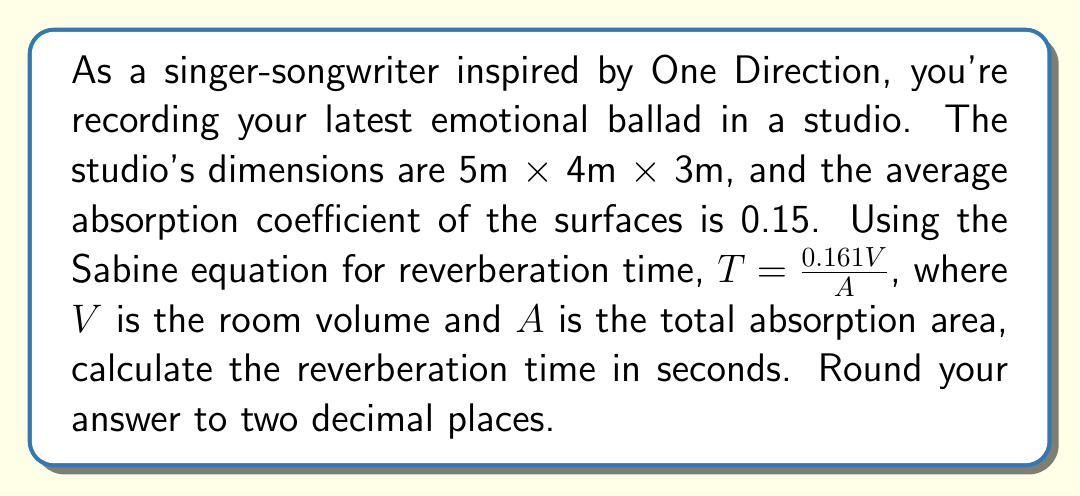Could you help me with this problem? Let's approach this step-by-step:

1) First, we need to calculate the volume of the room:
   $V = 5m \times 4m \times 3m = 60m^3$

2) Next, we need to calculate the total surface area of the room:
   $S = 2(5 \times 4 + 5 \times 3 + 4 \times 3) = 94m^2$

3) The total absorption area $A$ is the product of the surface area and the average absorption coefficient:
   $A = 94m^2 \times 0.15 = 14.1m^2$

4) Now we can plug these values into the Sabine equation:

   $T = \frac{0.161V}{A}$

   $T = \frac{0.161 \times 60m^3}{14.1m^2}$

   $T = \frac{9.66}{14.1} = 0.6851 \text{ seconds}$

5) Rounding to two decimal places:
   $T \approx 0.69 \text{ seconds}$
Answer: 0.69 seconds 